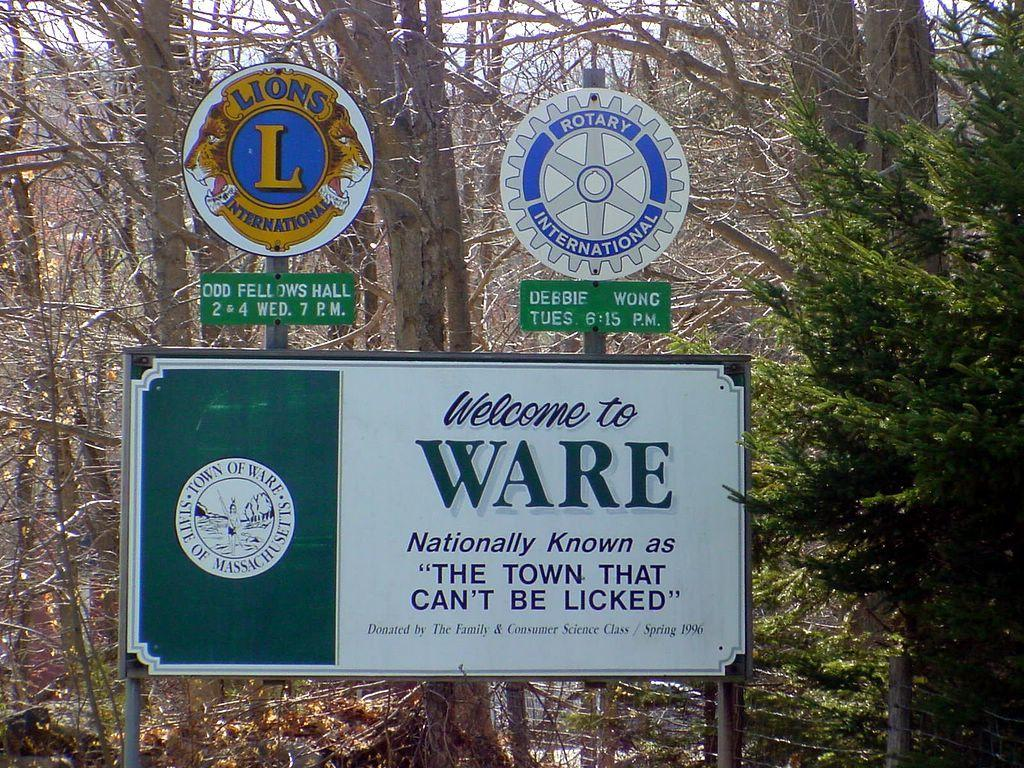Provide a one-sentence caption for the provided image. The sign welcomes you to Ware, the town that can't be licked. 